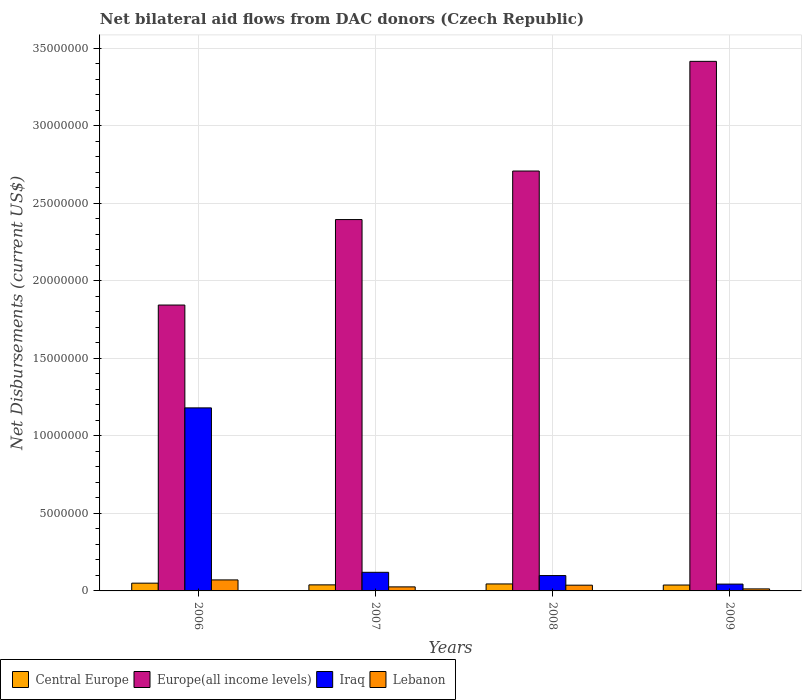How many different coloured bars are there?
Your response must be concise. 4. How many groups of bars are there?
Your response must be concise. 4. Are the number of bars per tick equal to the number of legend labels?
Make the answer very short. Yes. Are the number of bars on each tick of the X-axis equal?
Give a very brief answer. Yes. How many bars are there on the 2nd tick from the left?
Offer a terse response. 4. How many bars are there on the 1st tick from the right?
Ensure brevity in your answer.  4. What is the label of the 4th group of bars from the left?
Your answer should be compact. 2009. In how many cases, is the number of bars for a given year not equal to the number of legend labels?
Your answer should be compact. 0. What is the net bilateral aid flows in Europe(all income levels) in 2009?
Ensure brevity in your answer.  3.41e+07. Across all years, what is the maximum net bilateral aid flows in Iraq?
Provide a succinct answer. 1.18e+07. Across all years, what is the minimum net bilateral aid flows in Lebanon?
Offer a very short reply. 1.30e+05. In which year was the net bilateral aid flows in Lebanon minimum?
Make the answer very short. 2009. What is the total net bilateral aid flows in Iraq in the graph?
Your response must be concise. 1.44e+07. What is the difference between the net bilateral aid flows in Iraq in 2007 and that in 2008?
Offer a very short reply. 2.10e+05. What is the average net bilateral aid flows in Lebanon per year?
Offer a terse response. 3.68e+05. In the year 2006, what is the difference between the net bilateral aid flows in Iraq and net bilateral aid flows in Europe(all income levels)?
Your answer should be very brief. -6.63e+06. What is the ratio of the net bilateral aid flows in Lebanon in 2006 to that in 2007?
Keep it short and to the point. 2.73. Is the net bilateral aid flows in Lebanon in 2008 less than that in 2009?
Provide a short and direct response. No. What is the difference between the highest and the second highest net bilateral aid flows in Europe(all income levels)?
Offer a very short reply. 7.07e+06. What is the difference between the highest and the lowest net bilateral aid flows in Lebanon?
Provide a succinct answer. 5.80e+05. In how many years, is the net bilateral aid flows in Central Europe greater than the average net bilateral aid flows in Central Europe taken over all years?
Provide a short and direct response. 2. Is the sum of the net bilateral aid flows in Lebanon in 2006 and 2009 greater than the maximum net bilateral aid flows in Europe(all income levels) across all years?
Make the answer very short. No. Is it the case that in every year, the sum of the net bilateral aid flows in Central Europe and net bilateral aid flows in Iraq is greater than the sum of net bilateral aid flows in Lebanon and net bilateral aid flows in Europe(all income levels)?
Ensure brevity in your answer.  No. What does the 2nd bar from the left in 2006 represents?
Your response must be concise. Europe(all income levels). What does the 1st bar from the right in 2008 represents?
Your answer should be very brief. Lebanon. How many bars are there?
Provide a short and direct response. 16. How many years are there in the graph?
Ensure brevity in your answer.  4. Does the graph contain any zero values?
Your answer should be compact. No. Where does the legend appear in the graph?
Make the answer very short. Bottom left. How are the legend labels stacked?
Your answer should be compact. Horizontal. What is the title of the graph?
Offer a very short reply. Net bilateral aid flows from DAC donors (Czech Republic). Does "Cote d'Ivoire" appear as one of the legend labels in the graph?
Give a very brief answer. No. What is the label or title of the Y-axis?
Provide a short and direct response. Net Disbursements (current US$). What is the Net Disbursements (current US$) in Central Europe in 2006?
Keep it short and to the point. 5.00e+05. What is the Net Disbursements (current US$) in Europe(all income levels) in 2006?
Give a very brief answer. 1.84e+07. What is the Net Disbursements (current US$) in Iraq in 2006?
Make the answer very short. 1.18e+07. What is the Net Disbursements (current US$) in Lebanon in 2006?
Keep it short and to the point. 7.10e+05. What is the Net Disbursements (current US$) in Central Europe in 2007?
Offer a very short reply. 3.90e+05. What is the Net Disbursements (current US$) in Europe(all income levels) in 2007?
Make the answer very short. 2.39e+07. What is the Net Disbursements (current US$) of Iraq in 2007?
Keep it short and to the point. 1.20e+06. What is the Net Disbursements (current US$) of Europe(all income levels) in 2008?
Provide a short and direct response. 2.71e+07. What is the Net Disbursements (current US$) in Iraq in 2008?
Your answer should be very brief. 9.90e+05. What is the Net Disbursements (current US$) of Europe(all income levels) in 2009?
Your answer should be very brief. 3.41e+07. What is the Net Disbursements (current US$) of Lebanon in 2009?
Offer a terse response. 1.30e+05. Across all years, what is the maximum Net Disbursements (current US$) of Central Europe?
Make the answer very short. 5.00e+05. Across all years, what is the maximum Net Disbursements (current US$) of Europe(all income levels)?
Offer a terse response. 3.41e+07. Across all years, what is the maximum Net Disbursements (current US$) of Iraq?
Provide a short and direct response. 1.18e+07. Across all years, what is the maximum Net Disbursements (current US$) in Lebanon?
Ensure brevity in your answer.  7.10e+05. Across all years, what is the minimum Net Disbursements (current US$) in Central Europe?
Give a very brief answer. 3.80e+05. Across all years, what is the minimum Net Disbursements (current US$) of Europe(all income levels)?
Ensure brevity in your answer.  1.84e+07. Across all years, what is the minimum Net Disbursements (current US$) in Lebanon?
Give a very brief answer. 1.30e+05. What is the total Net Disbursements (current US$) of Central Europe in the graph?
Give a very brief answer. 1.72e+06. What is the total Net Disbursements (current US$) in Europe(all income levels) in the graph?
Provide a succinct answer. 1.04e+08. What is the total Net Disbursements (current US$) of Iraq in the graph?
Make the answer very short. 1.44e+07. What is the total Net Disbursements (current US$) in Lebanon in the graph?
Provide a short and direct response. 1.47e+06. What is the difference between the Net Disbursements (current US$) in Central Europe in 2006 and that in 2007?
Give a very brief answer. 1.10e+05. What is the difference between the Net Disbursements (current US$) of Europe(all income levels) in 2006 and that in 2007?
Provide a succinct answer. -5.51e+06. What is the difference between the Net Disbursements (current US$) of Iraq in 2006 and that in 2007?
Your response must be concise. 1.06e+07. What is the difference between the Net Disbursements (current US$) in Europe(all income levels) in 2006 and that in 2008?
Offer a terse response. -8.64e+06. What is the difference between the Net Disbursements (current US$) in Iraq in 2006 and that in 2008?
Your answer should be compact. 1.08e+07. What is the difference between the Net Disbursements (current US$) of Lebanon in 2006 and that in 2008?
Keep it short and to the point. 3.40e+05. What is the difference between the Net Disbursements (current US$) of Central Europe in 2006 and that in 2009?
Offer a terse response. 1.20e+05. What is the difference between the Net Disbursements (current US$) in Europe(all income levels) in 2006 and that in 2009?
Your answer should be very brief. -1.57e+07. What is the difference between the Net Disbursements (current US$) in Iraq in 2006 and that in 2009?
Provide a short and direct response. 1.14e+07. What is the difference between the Net Disbursements (current US$) of Lebanon in 2006 and that in 2009?
Offer a very short reply. 5.80e+05. What is the difference between the Net Disbursements (current US$) of Europe(all income levels) in 2007 and that in 2008?
Your response must be concise. -3.13e+06. What is the difference between the Net Disbursements (current US$) of Iraq in 2007 and that in 2008?
Your answer should be compact. 2.10e+05. What is the difference between the Net Disbursements (current US$) in Europe(all income levels) in 2007 and that in 2009?
Keep it short and to the point. -1.02e+07. What is the difference between the Net Disbursements (current US$) of Iraq in 2007 and that in 2009?
Your answer should be very brief. 7.60e+05. What is the difference between the Net Disbursements (current US$) of Lebanon in 2007 and that in 2009?
Provide a short and direct response. 1.30e+05. What is the difference between the Net Disbursements (current US$) in Europe(all income levels) in 2008 and that in 2009?
Your response must be concise. -7.07e+06. What is the difference between the Net Disbursements (current US$) in Iraq in 2008 and that in 2009?
Provide a short and direct response. 5.50e+05. What is the difference between the Net Disbursements (current US$) of Lebanon in 2008 and that in 2009?
Provide a short and direct response. 2.40e+05. What is the difference between the Net Disbursements (current US$) in Central Europe in 2006 and the Net Disbursements (current US$) in Europe(all income levels) in 2007?
Give a very brief answer. -2.34e+07. What is the difference between the Net Disbursements (current US$) in Central Europe in 2006 and the Net Disbursements (current US$) in Iraq in 2007?
Offer a terse response. -7.00e+05. What is the difference between the Net Disbursements (current US$) in Europe(all income levels) in 2006 and the Net Disbursements (current US$) in Iraq in 2007?
Ensure brevity in your answer.  1.72e+07. What is the difference between the Net Disbursements (current US$) in Europe(all income levels) in 2006 and the Net Disbursements (current US$) in Lebanon in 2007?
Give a very brief answer. 1.82e+07. What is the difference between the Net Disbursements (current US$) in Iraq in 2006 and the Net Disbursements (current US$) in Lebanon in 2007?
Offer a very short reply. 1.15e+07. What is the difference between the Net Disbursements (current US$) of Central Europe in 2006 and the Net Disbursements (current US$) of Europe(all income levels) in 2008?
Keep it short and to the point. -2.66e+07. What is the difference between the Net Disbursements (current US$) in Central Europe in 2006 and the Net Disbursements (current US$) in Iraq in 2008?
Your response must be concise. -4.90e+05. What is the difference between the Net Disbursements (current US$) of Europe(all income levels) in 2006 and the Net Disbursements (current US$) of Iraq in 2008?
Provide a short and direct response. 1.74e+07. What is the difference between the Net Disbursements (current US$) in Europe(all income levels) in 2006 and the Net Disbursements (current US$) in Lebanon in 2008?
Give a very brief answer. 1.81e+07. What is the difference between the Net Disbursements (current US$) in Iraq in 2006 and the Net Disbursements (current US$) in Lebanon in 2008?
Provide a succinct answer. 1.14e+07. What is the difference between the Net Disbursements (current US$) in Central Europe in 2006 and the Net Disbursements (current US$) in Europe(all income levels) in 2009?
Offer a terse response. -3.36e+07. What is the difference between the Net Disbursements (current US$) of Central Europe in 2006 and the Net Disbursements (current US$) of Iraq in 2009?
Offer a terse response. 6.00e+04. What is the difference between the Net Disbursements (current US$) of Europe(all income levels) in 2006 and the Net Disbursements (current US$) of Iraq in 2009?
Your answer should be compact. 1.80e+07. What is the difference between the Net Disbursements (current US$) in Europe(all income levels) in 2006 and the Net Disbursements (current US$) in Lebanon in 2009?
Make the answer very short. 1.83e+07. What is the difference between the Net Disbursements (current US$) of Iraq in 2006 and the Net Disbursements (current US$) of Lebanon in 2009?
Keep it short and to the point. 1.17e+07. What is the difference between the Net Disbursements (current US$) in Central Europe in 2007 and the Net Disbursements (current US$) in Europe(all income levels) in 2008?
Offer a terse response. -2.67e+07. What is the difference between the Net Disbursements (current US$) of Central Europe in 2007 and the Net Disbursements (current US$) of Iraq in 2008?
Your answer should be compact. -6.00e+05. What is the difference between the Net Disbursements (current US$) of Central Europe in 2007 and the Net Disbursements (current US$) of Lebanon in 2008?
Keep it short and to the point. 2.00e+04. What is the difference between the Net Disbursements (current US$) in Europe(all income levels) in 2007 and the Net Disbursements (current US$) in Iraq in 2008?
Make the answer very short. 2.30e+07. What is the difference between the Net Disbursements (current US$) of Europe(all income levels) in 2007 and the Net Disbursements (current US$) of Lebanon in 2008?
Your answer should be compact. 2.36e+07. What is the difference between the Net Disbursements (current US$) in Iraq in 2007 and the Net Disbursements (current US$) in Lebanon in 2008?
Provide a short and direct response. 8.30e+05. What is the difference between the Net Disbursements (current US$) of Central Europe in 2007 and the Net Disbursements (current US$) of Europe(all income levels) in 2009?
Offer a very short reply. -3.38e+07. What is the difference between the Net Disbursements (current US$) in Europe(all income levels) in 2007 and the Net Disbursements (current US$) in Iraq in 2009?
Your response must be concise. 2.35e+07. What is the difference between the Net Disbursements (current US$) of Europe(all income levels) in 2007 and the Net Disbursements (current US$) of Lebanon in 2009?
Make the answer very short. 2.38e+07. What is the difference between the Net Disbursements (current US$) in Iraq in 2007 and the Net Disbursements (current US$) in Lebanon in 2009?
Give a very brief answer. 1.07e+06. What is the difference between the Net Disbursements (current US$) in Central Europe in 2008 and the Net Disbursements (current US$) in Europe(all income levels) in 2009?
Keep it short and to the point. -3.37e+07. What is the difference between the Net Disbursements (current US$) in Europe(all income levels) in 2008 and the Net Disbursements (current US$) in Iraq in 2009?
Offer a terse response. 2.66e+07. What is the difference between the Net Disbursements (current US$) in Europe(all income levels) in 2008 and the Net Disbursements (current US$) in Lebanon in 2009?
Provide a succinct answer. 2.69e+07. What is the difference between the Net Disbursements (current US$) of Iraq in 2008 and the Net Disbursements (current US$) of Lebanon in 2009?
Provide a succinct answer. 8.60e+05. What is the average Net Disbursements (current US$) of Europe(all income levels) per year?
Offer a very short reply. 2.59e+07. What is the average Net Disbursements (current US$) of Iraq per year?
Provide a short and direct response. 3.61e+06. What is the average Net Disbursements (current US$) of Lebanon per year?
Your answer should be very brief. 3.68e+05. In the year 2006, what is the difference between the Net Disbursements (current US$) of Central Europe and Net Disbursements (current US$) of Europe(all income levels)?
Your response must be concise. -1.79e+07. In the year 2006, what is the difference between the Net Disbursements (current US$) of Central Europe and Net Disbursements (current US$) of Iraq?
Offer a terse response. -1.13e+07. In the year 2006, what is the difference between the Net Disbursements (current US$) in Europe(all income levels) and Net Disbursements (current US$) in Iraq?
Your answer should be compact. 6.63e+06. In the year 2006, what is the difference between the Net Disbursements (current US$) in Europe(all income levels) and Net Disbursements (current US$) in Lebanon?
Provide a short and direct response. 1.77e+07. In the year 2006, what is the difference between the Net Disbursements (current US$) of Iraq and Net Disbursements (current US$) of Lebanon?
Offer a terse response. 1.11e+07. In the year 2007, what is the difference between the Net Disbursements (current US$) of Central Europe and Net Disbursements (current US$) of Europe(all income levels)?
Give a very brief answer. -2.36e+07. In the year 2007, what is the difference between the Net Disbursements (current US$) in Central Europe and Net Disbursements (current US$) in Iraq?
Provide a succinct answer. -8.10e+05. In the year 2007, what is the difference between the Net Disbursements (current US$) of Europe(all income levels) and Net Disbursements (current US$) of Iraq?
Offer a very short reply. 2.27e+07. In the year 2007, what is the difference between the Net Disbursements (current US$) in Europe(all income levels) and Net Disbursements (current US$) in Lebanon?
Ensure brevity in your answer.  2.37e+07. In the year 2007, what is the difference between the Net Disbursements (current US$) of Iraq and Net Disbursements (current US$) of Lebanon?
Provide a short and direct response. 9.40e+05. In the year 2008, what is the difference between the Net Disbursements (current US$) in Central Europe and Net Disbursements (current US$) in Europe(all income levels)?
Your answer should be compact. -2.66e+07. In the year 2008, what is the difference between the Net Disbursements (current US$) in Central Europe and Net Disbursements (current US$) in Iraq?
Your response must be concise. -5.40e+05. In the year 2008, what is the difference between the Net Disbursements (current US$) in Europe(all income levels) and Net Disbursements (current US$) in Iraq?
Make the answer very short. 2.61e+07. In the year 2008, what is the difference between the Net Disbursements (current US$) of Europe(all income levels) and Net Disbursements (current US$) of Lebanon?
Give a very brief answer. 2.67e+07. In the year 2008, what is the difference between the Net Disbursements (current US$) of Iraq and Net Disbursements (current US$) of Lebanon?
Keep it short and to the point. 6.20e+05. In the year 2009, what is the difference between the Net Disbursements (current US$) of Central Europe and Net Disbursements (current US$) of Europe(all income levels)?
Provide a short and direct response. -3.38e+07. In the year 2009, what is the difference between the Net Disbursements (current US$) in Central Europe and Net Disbursements (current US$) in Iraq?
Provide a short and direct response. -6.00e+04. In the year 2009, what is the difference between the Net Disbursements (current US$) in Europe(all income levels) and Net Disbursements (current US$) in Iraq?
Your answer should be very brief. 3.37e+07. In the year 2009, what is the difference between the Net Disbursements (current US$) in Europe(all income levels) and Net Disbursements (current US$) in Lebanon?
Give a very brief answer. 3.40e+07. What is the ratio of the Net Disbursements (current US$) of Central Europe in 2006 to that in 2007?
Give a very brief answer. 1.28. What is the ratio of the Net Disbursements (current US$) of Europe(all income levels) in 2006 to that in 2007?
Provide a succinct answer. 0.77. What is the ratio of the Net Disbursements (current US$) of Iraq in 2006 to that in 2007?
Provide a succinct answer. 9.83. What is the ratio of the Net Disbursements (current US$) of Lebanon in 2006 to that in 2007?
Your answer should be compact. 2.73. What is the ratio of the Net Disbursements (current US$) of Europe(all income levels) in 2006 to that in 2008?
Keep it short and to the point. 0.68. What is the ratio of the Net Disbursements (current US$) in Iraq in 2006 to that in 2008?
Give a very brief answer. 11.92. What is the ratio of the Net Disbursements (current US$) of Lebanon in 2006 to that in 2008?
Your response must be concise. 1.92. What is the ratio of the Net Disbursements (current US$) of Central Europe in 2006 to that in 2009?
Provide a short and direct response. 1.32. What is the ratio of the Net Disbursements (current US$) in Europe(all income levels) in 2006 to that in 2009?
Your answer should be very brief. 0.54. What is the ratio of the Net Disbursements (current US$) of Iraq in 2006 to that in 2009?
Provide a short and direct response. 26.82. What is the ratio of the Net Disbursements (current US$) of Lebanon in 2006 to that in 2009?
Your answer should be compact. 5.46. What is the ratio of the Net Disbursements (current US$) of Central Europe in 2007 to that in 2008?
Your response must be concise. 0.87. What is the ratio of the Net Disbursements (current US$) of Europe(all income levels) in 2007 to that in 2008?
Provide a short and direct response. 0.88. What is the ratio of the Net Disbursements (current US$) of Iraq in 2007 to that in 2008?
Provide a succinct answer. 1.21. What is the ratio of the Net Disbursements (current US$) in Lebanon in 2007 to that in 2008?
Provide a succinct answer. 0.7. What is the ratio of the Net Disbursements (current US$) in Central Europe in 2007 to that in 2009?
Make the answer very short. 1.03. What is the ratio of the Net Disbursements (current US$) of Europe(all income levels) in 2007 to that in 2009?
Keep it short and to the point. 0.7. What is the ratio of the Net Disbursements (current US$) of Iraq in 2007 to that in 2009?
Keep it short and to the point. 2.73. What is the ratio of the Net Disbursements (current US$) in Central Europe in 2008 to that in 2009?
Provide a succinct answer. 1.18. What is the ratio of the Net Disbursements (current US$) in Europe(all income levels) in 2008 to that in 2009?
Give a very brief answer. 0.79. What is the ratio of the Net Disbursements (current US$) of Iraq in 2008 to that in 2009?
Ensure brevity in your answer.  2.25. What is the ratio of the Net Disbursements (current US$) of Lebanon in 2008 to that in 2009?
Offer a terse response. 2.85. What is the difference between the highest and the second highest Net Disbursements (current US$) of Central Europe?
Keep it short and to the point. 5.00e+04. What is the difference between the highest and the second highest Net Disbursements (current US$) in Europe(all income levels)?
Ensure brevity in your answer.  7.07e+06. What is the difference between the highest and the second highest Net Disbursements (current US$) of Iraq?
Make the answer very short. 1.06e+07. What is the difference between the highest and the second highest Net Disbursements (current US$) in Lebanon?
Ensure brevity in your answer.  3.40e+05. What is the difference between the highest and the lowest Net Disbursements (current US$) in Central Europe?
Offer a terse response. 1.20e+05. What is the difference between the highest and the lowest Net Disbursements (current US$) of Europe(all income levels)?
Ensure brevity in your answer.  1.57e+07. What is the difference between the highest and the lowest Net Disbursements (current US$) of Iraq?
Keep it short and to the point. 1.14e+07. What is the difference between the highest and the lowest Net Disbursements (current US$) in Lebanon?
Make the answer very short. 5.80e+05. 